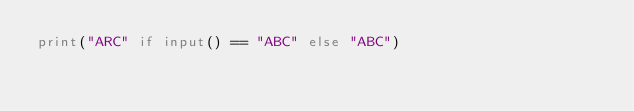<code> <loc_0><loc_0><loc_500><loc_500><_Python_>print("ARC" if input() == "ABC" else "ABC")
</code> 